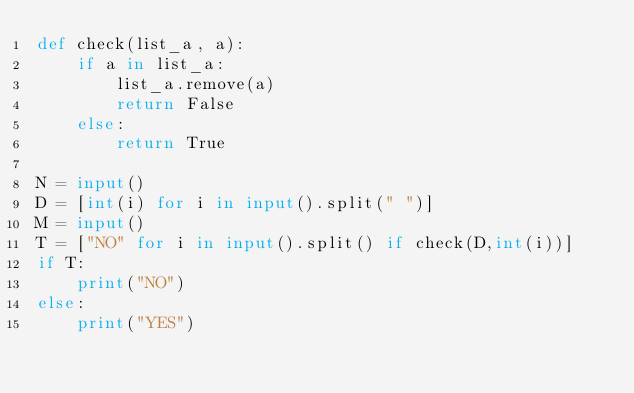Convert code to text. <code><loc_0><loc_0><loc_500><loc_500><_Python_>def check(list_a, a):
    if a in list_a:
        list_a.remove(a)
        return False
    else:
        return True

N = input()
D = [int(i) for i in input().split(" ")]
M = input()
T = ["NO" for i in input().split() if check(D,int(i))]
if T:
    print("NO")
else:
    print("YES")</code> 